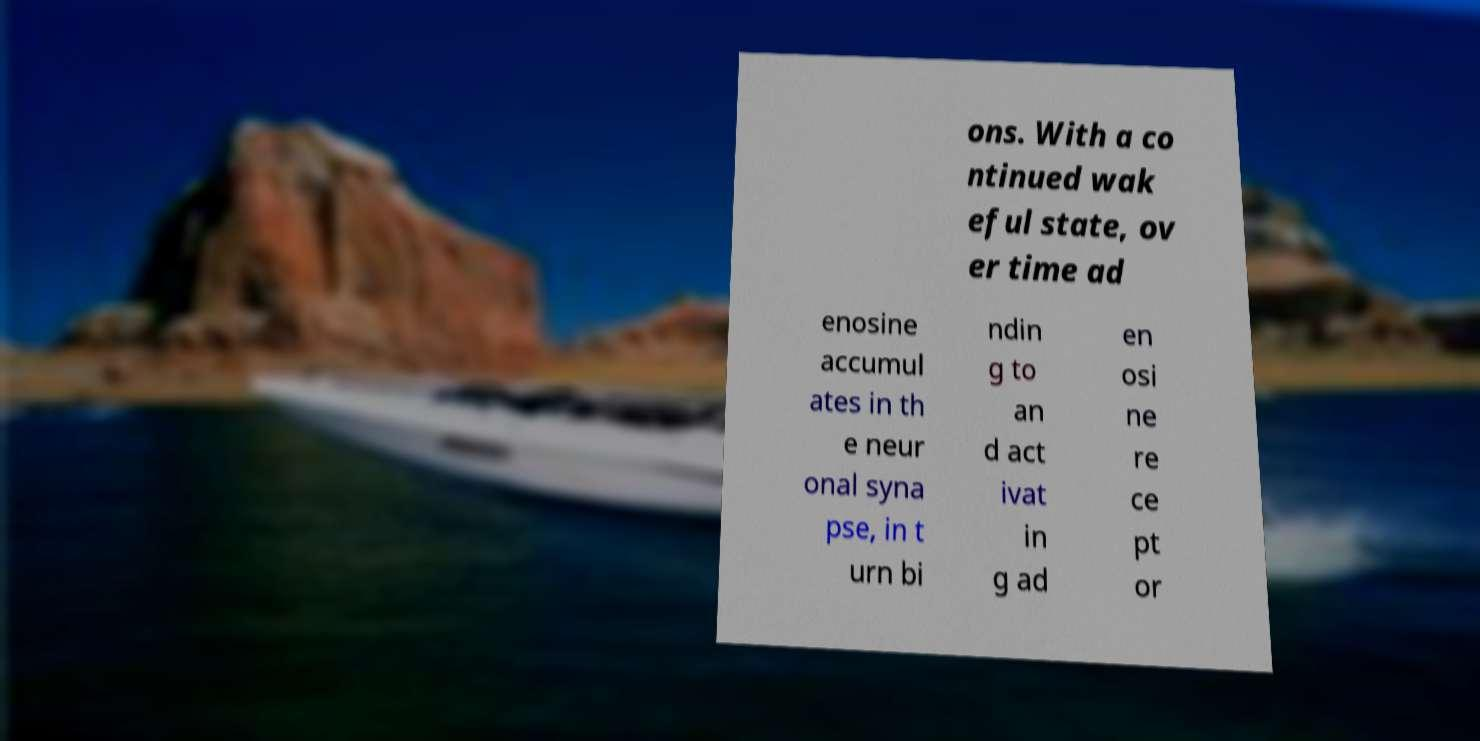Can you accurately transcribe the text from the provided image for me? ons. With a co ntinued wak eful state, ov er time ad enosine accumul ates in th e neur onal syna pse, in t urn bi ndin g to an d act ivat in g ad en osi ne re ce pt or 